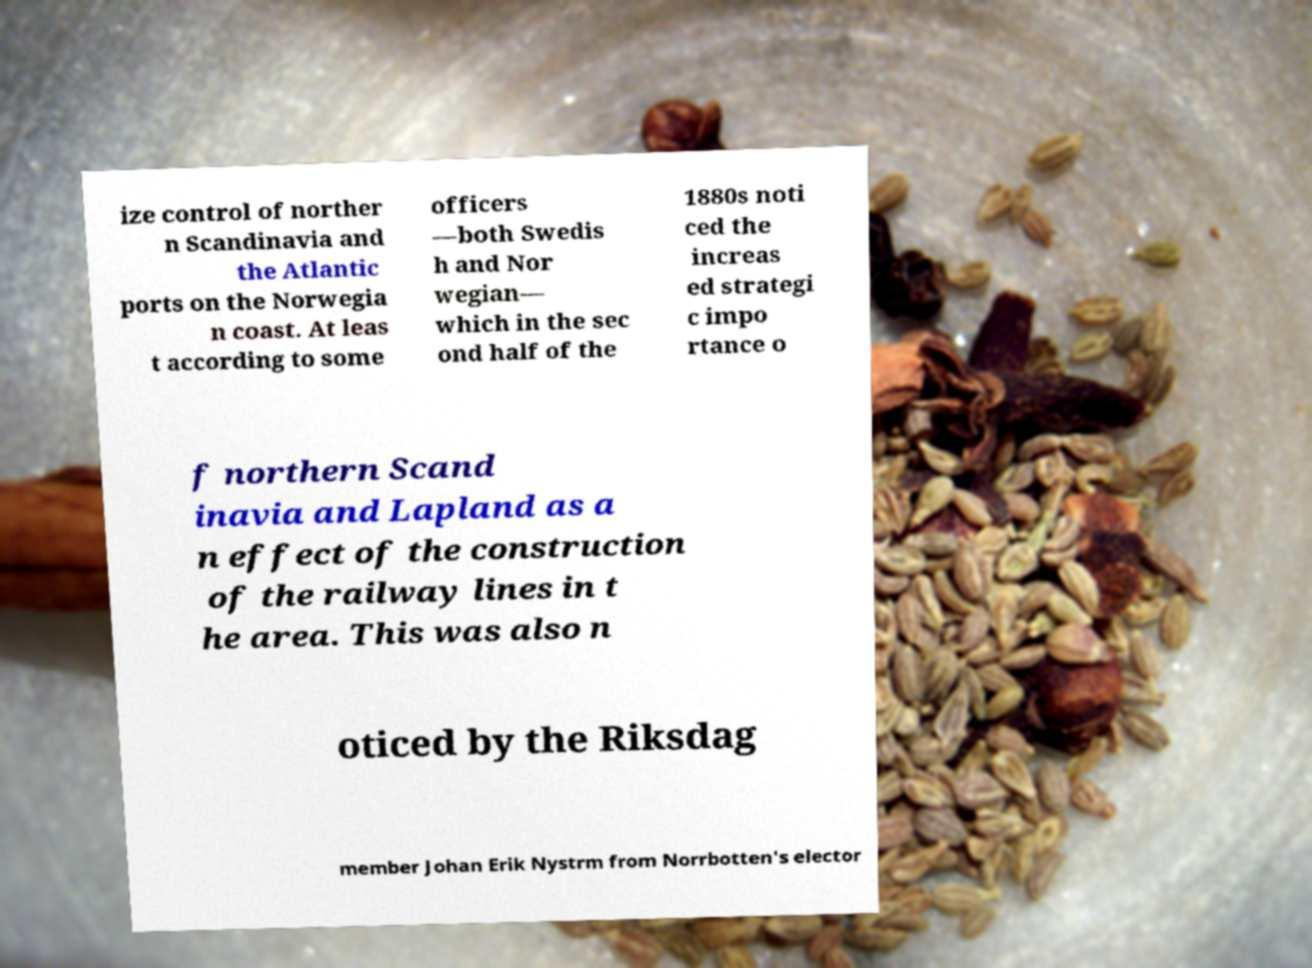There's text embedded in this image that I need extracted. Can you transcribe it verbatim? ize control of norther n Scandinavia and the Atlantic ports on the Norwegia n coast. At leas t according to some officers —both Swedis h and Nor wegian— which in the sec ond half of the 1880s noti ced the increas ed strategi c impo rtance o f northern Scand inavia and Lapland as a n effect of the construction of the railway lines in t he area. This was also n oticed by the Riksdag member Johan Erik Nystrm from Norrbotten's elector 